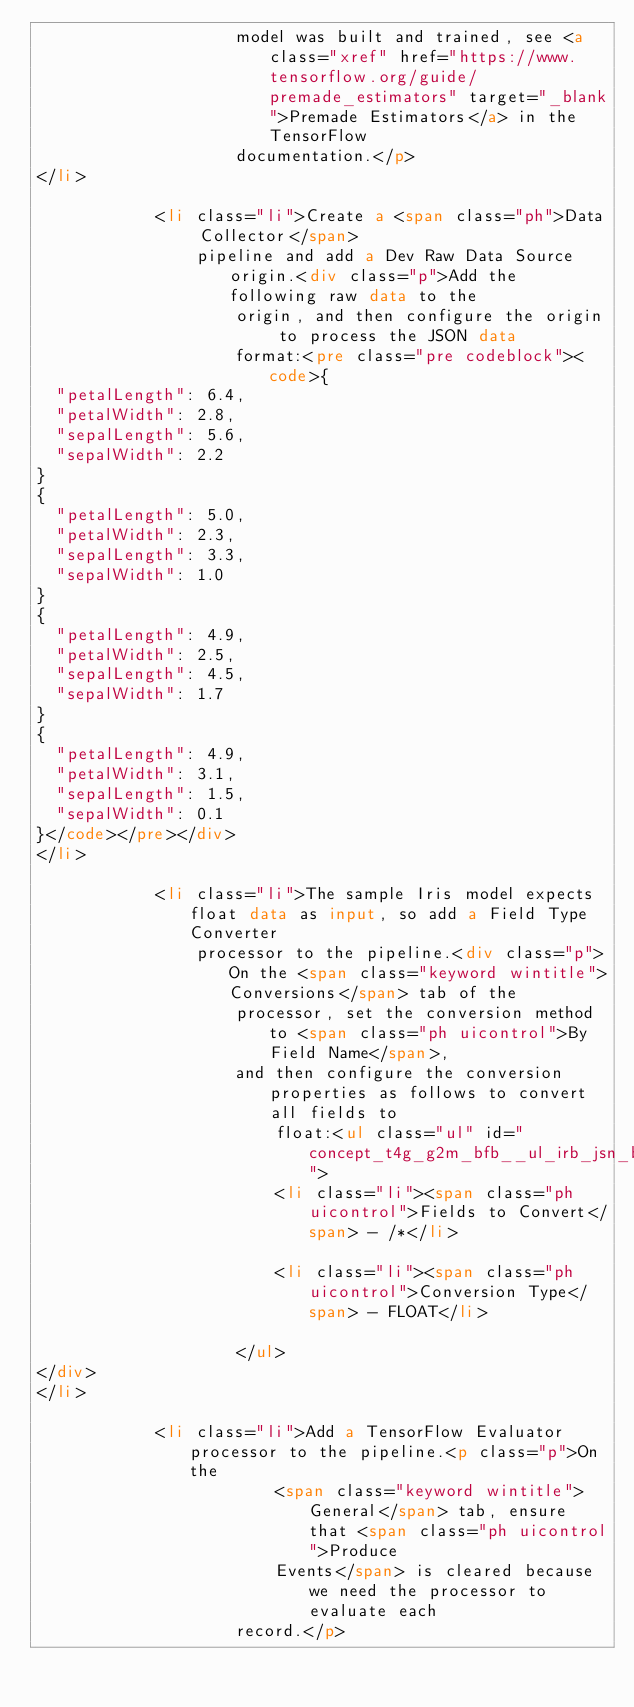Convert code to text. <code><loc_0><loc_0><loc_500><loc_500><_HTML_>                    model was built and trained, see <a class="xref" href="https://www.tensorflow.org/guide/premade_estimators" target="_blank">Premade Estimators</a> in the TensorFlow
                    documentation.</p>
</li>

            <li class="li">Create a <span class="ph">Data Collector</span>
                pipeline and add a Dev Raw Data Source origin.<div class="p">Add the following raw data to the
                    origin, and then configure the origin to process the JSON data
                    format:<pre class="pre codeblock"><code>{
  "petalLength": 6.4,
  "petalWidth": 2.8,
  "sepalLength": 5.6,
  "sepalWidth": 2.2
}
{
  "petalLength": 5.0,
  "petalWidth": 2.3,
  "sepalLength": 3.3,
  "sepalWidth": 1.0
}
{
  "petalLength": 4.9,
  "petalWidth": 2.5,
  "sepalLength": 4.5,
  "sepalWidth": 1.7
}
{
  "petalLength": 4.9,
  "petalWidth": 3.1,
  "sepalLength": 1.5,
  "sepalWidth": 0.1
}</code></pre></div>
</li>

            <li class="li">The sample Iris model expects float data as input, so add a Field Type Converter
                processor to the pipeline.<div class="p">On the <span class="keyword wintitle">Conversions</span> tab of the
                    processor, set the conversion method to <span class="ph uicontrol">By Field Name</span>,
                    and then configure the conversion properties as follows to convert all fields to
                        float:<ul class="ul" id="concept_t4g_g2m_bfb__ul_irb_jsn_bfb">
                        <li class="li"><span class="ph uicontrol">Fields to Convert</span> - /*</li>

                        <li class="li"><span class="ph uicontrol">Conversion Type</span> - FLOAT</li>

                    </ul>
</div>
</li>

            <li class="li">Add a TensorFlow Evaluator processor to the pipeline.<p class="p">On the
                        <span class="keyword wintitle">General</span> tab, ensure that <span class="ph uicontrol">Produce
                        Events</span> is cleared because we need the processor to evaluate each
                    record.</p></code> 